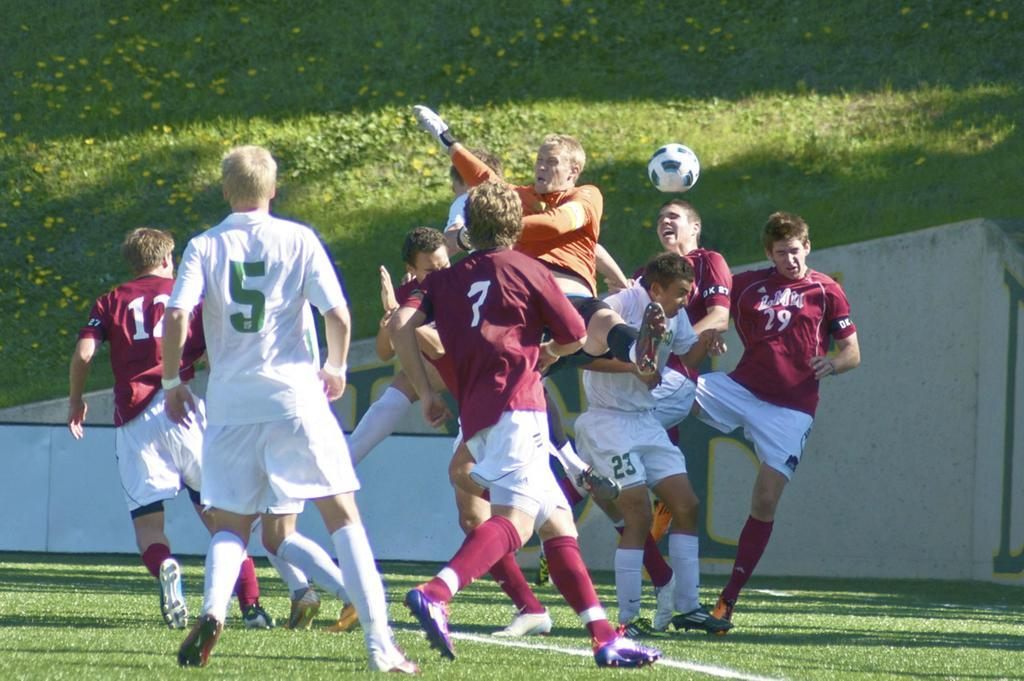How many people are in the image? There is a group of people in the image, but the exact number is not specified. What are the people doing in the image? The people are playing a game in the image. What object is involved in the game? There is a ball in the image, which is likely used in the game. What colors can be seen on the ball? The ball has white and black colors. What might be the surface on which the game is being played? The background of the image is green, likely representing grass, so the game might be played on a grassy surface. What type of liquid can be seen dripping from the ball in the image? There is no liquid dripping from the ball in the image; it is a solid object with white and black colors. 